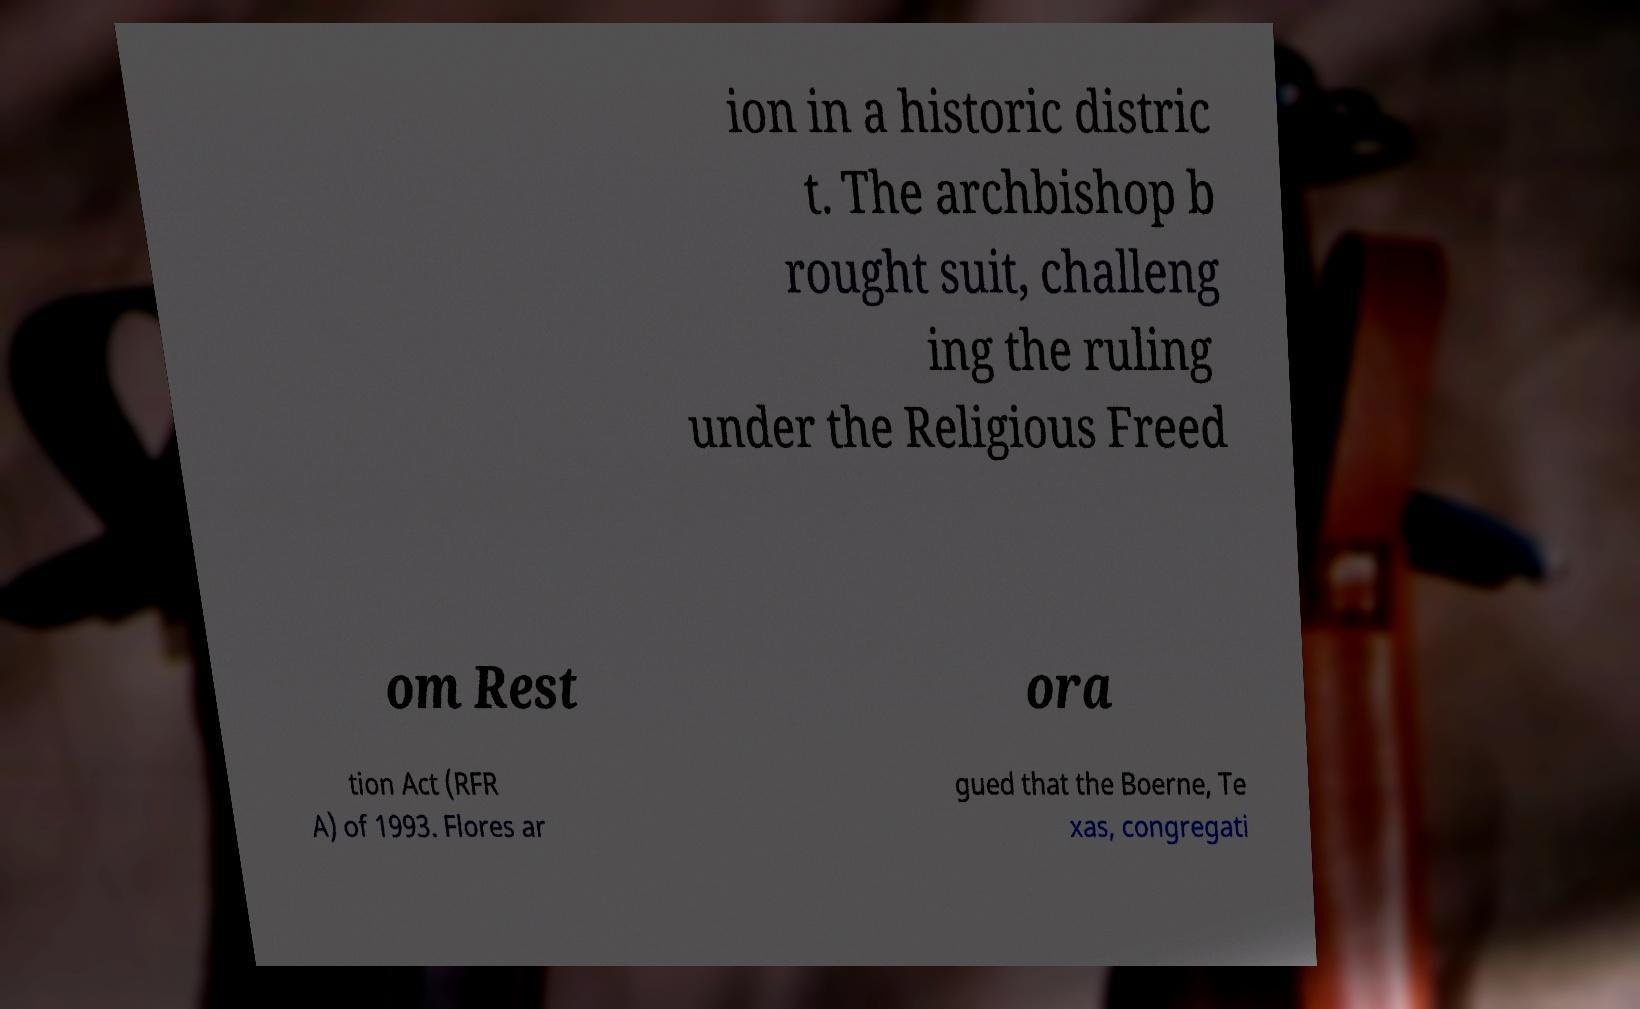Can you read and provide the text displayed in the image?This photo seems to have some interesting text. Can you extract and type it out for me? ion in a historic distric t. The archbishop b rought suit, challeng ing the ruling under the Religious Freed om Rest ora tion Act (RFR A) of 1993. Flores ar gued that the Boerne, Te xas, congregati 